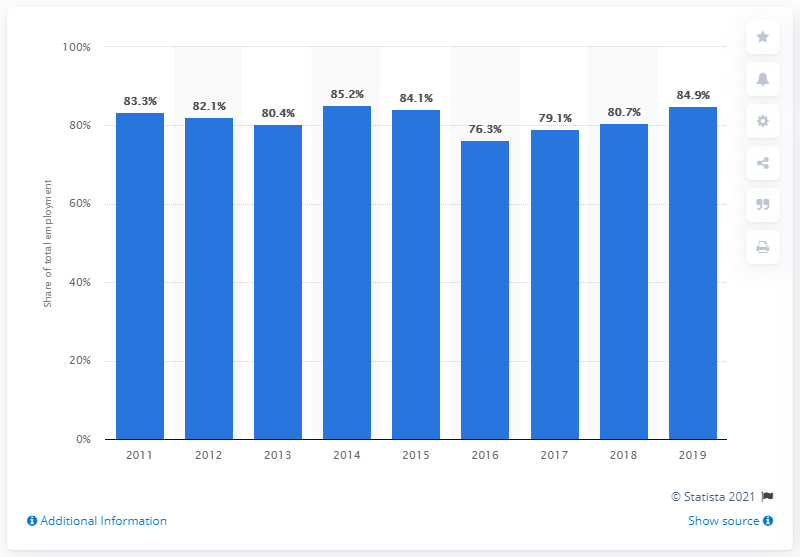Outline some significant characteristics in this image. In 2019, the percentage of informal employment in Bolivia was 84.9%. According to data from the Bolivian Labor Ministry, 80.7% of Bolivian workers were considered informally employed in 2020. 